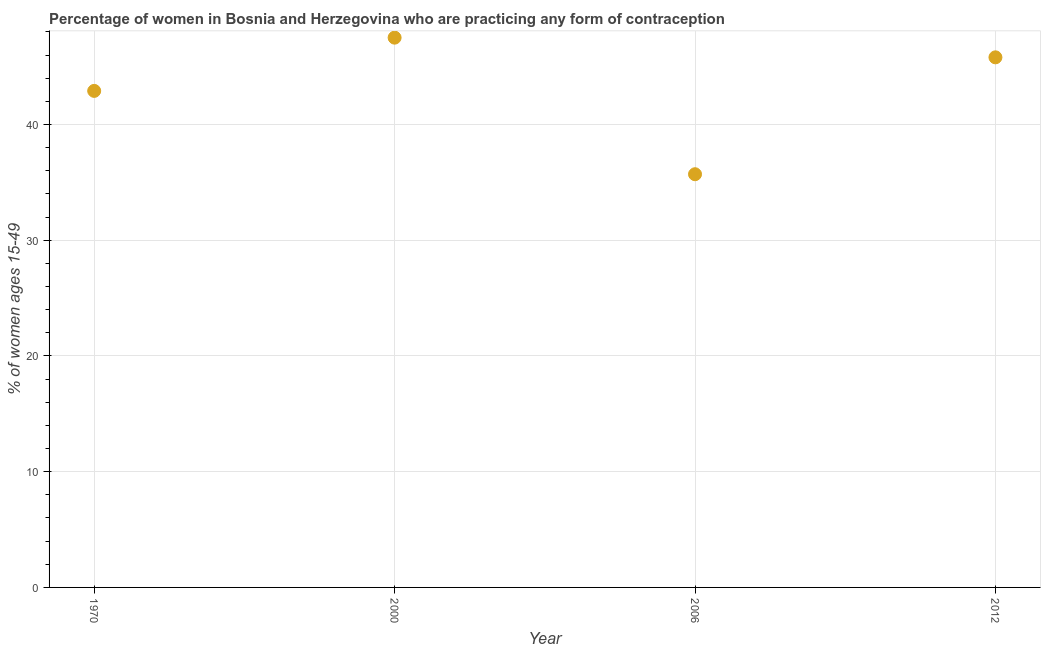What is the contraceptive prevalence in 2012?
Make the answer very short. 45.8. Across all years, what is the maximum contraceptive prevalence?
Your response must be concise. 47.5. Across all years, what is the minimum contraceptive prevalence?
Your answer should be very brief. 35.7. In which year was the contraceptive prevalence minimum?
Offer a very short reply. 2006. What is the sum of the contraceptive prevalence?
Offer a very short reply. 171.9. What is the difference between the contraceptive prevalence in 2000 and 2006?
Offer a terse response. 11.8. What is the average contraceptive prevalence per year?
Keep it short and to the point. 42.98. What is the median contraceptive prevalence?
Your answer should be compact. 44.35. In how many years, is the contraceptive prevalence greater than 26 %?
Provide a short and direct response. 4. Do a majority of the years between 2000 and 2012 (inclusive) have contraceptive prevalence greater than 28 %?
Ensure brevity in your answer.  Yes. What is the ratio of the contraceptive prevalence in 1970 to that in 2000?
Your answer should be very brief. 0.9. What is the difference between the highest and the second highest contraceptive prevalence?
Your answer should be very brief. 1.7. Is the sum of the contraceptive prevalence in 2000 and 2012 greater than the maximum contraceptive prevalence across all years?
Your answer should be compact. Yes. What is the difference between the highest and the lowest contraceptive prevalence?
Your answer should be compact. 11.8. In how many years, is the contraceptive prevalence greater than the average contraceptive prevalence taken over all years?
Your answer should be very brief. 2. How many dotlines are there?
Your response must be concise. 1. Are the values on the major ticks of Y-axis written in scientific E-notation?
Your answer should be very brief. No. Does the graph contain grids?
Your answer should be very brief. Yes. What is the title of the graph?
Make the answer very short. Percentage of women in Bosnia and Herzegovina who are practicing any form of contraception. What is the label or title of the Y-axis?
Make the answer very short. % of women ages 15-49. What is the % of women ages 15-49 in 1970?
Offer a terse response. 42.9. What is the % of women ages 15-49 in 2000?
Offer a terse response. 47.5. What is the % of women ages 15-49 in 2006?
Offer a terse response. 35.7. What is the % of women ages 15-49 in 2012?
Provide a short and direct response. 45.8. What is the difference between the % of women ages 15-49 in 1970 and 2000?
Ensure brevity in your answer.  -4.6. What is the difference between the % of women ages 15-49 in 1970 and 2012?
Offer a terse response. -2.9. What is the ratio of the % of women ages 15-49 in 1970 to that in 2000?
Offer a very short reply. 0.9. What is the ratio of the % of women ages 15-49 in 1970 to that in 2006?
Make the answer very short. 1.2. What is the ratio of the % of women ages 15-49 in 1970 to that in 2012?
Provide a succinct answer. 0.94. What is the ratio of the % of women ages 15-49 in 2000 to that in 2006?
Offer a very short reply. 1.33. What is the ratio of the % of women ages 15-49 in 2006 to that in 2012?
Ensure brevity in your answer.  0.78. 